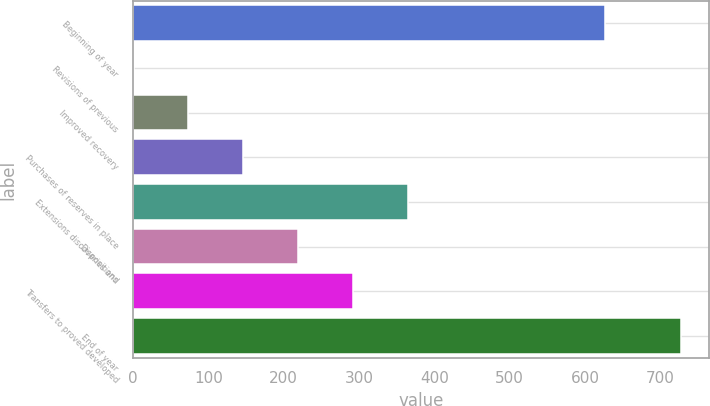Convert chart. <chart><loc_0><loc_0><loc_500><loc_500><bar_chart><fcel>Beginning of year<fcel>Revisions of previous<fcel>Improved recovery<fcel>Purchases of reserves in place<fcel>Extensions discoveries and<fcel>Dispositions<fcel>Transfers to proved developed<fcel>End of year<nl><fcel>627<fcel>1<fcel>73.7<fcel>146.4<fcel>364.5<fcel>219.1<fcel>291.8<fcel>728<nl></chart> 